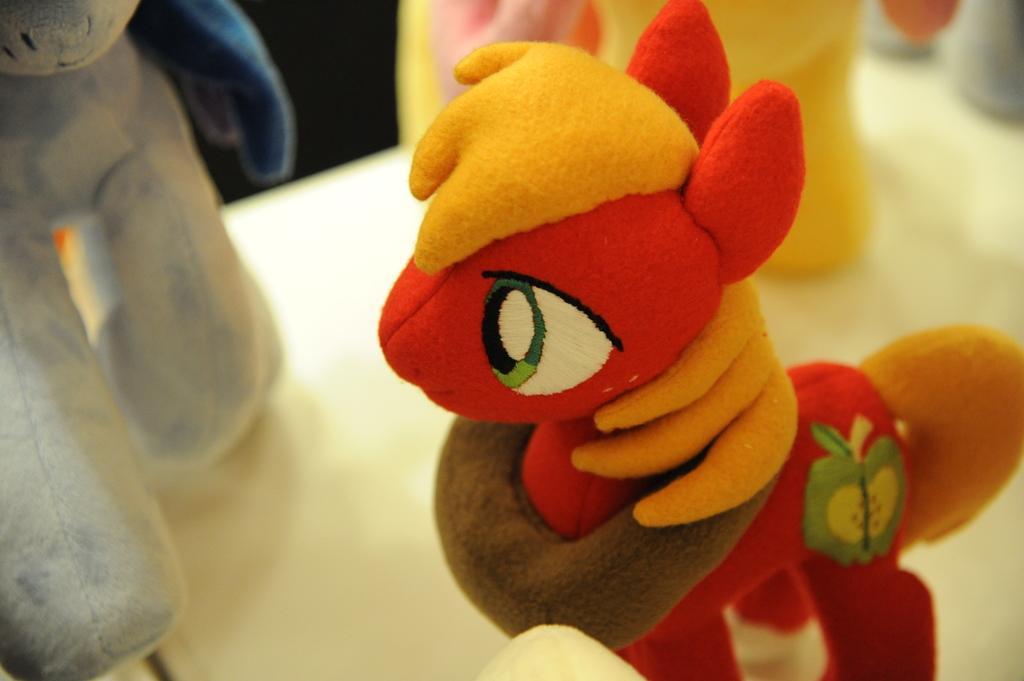Describe this image in one or two sentences. It is a zoom in picture of toys placed on the white surface. 